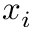Convert formula to latex. <formula><loc_0><loc_0><loc_500><loc_500>x _ { i }</formula> 